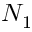Convert formula to latex. <formula><loc_0><loc_0><loc_500><loc_500>N _ { 1 }</formula> 